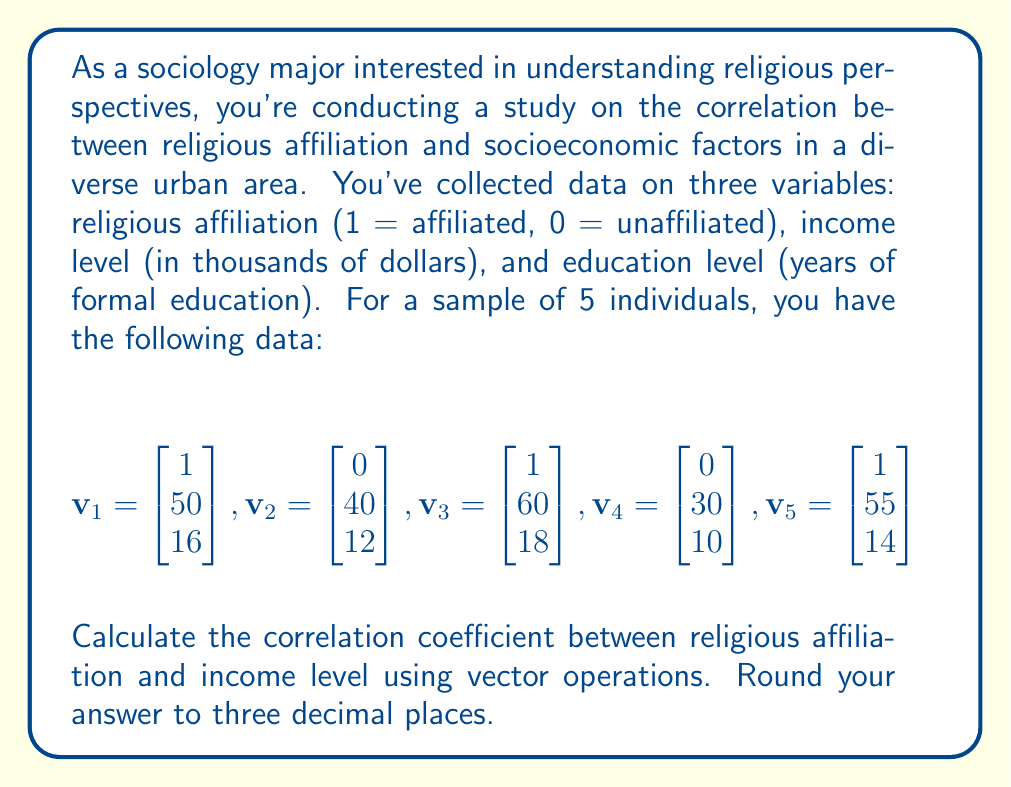Help me with this question. To calculate the correlation coefficient between religious affiliation and income level, we'll use the following steps:

1) First, we need to separate the religious affiliation data and income data into two vectors:

   $$\mathbf{x} = \begin{bmatrix} 1 \\ 0 \\ 1 \\ 0 \\ 1 \end{bmatrix}, \mathbf{y} = \begin{bmatrix} 50 \\ 40 \\ 60 \\ 30 \\ 55 \end{bmatrix}$$

2) Calculate the means of $\mathbf{x}$ and $\mathbf{y}$:
   
   $$\bar{x} = \frac{1}{5}(1+0+1+0+1) = 0.6$$
   $$\bar{y} = \frac{1}{5}(50+40+60+30+55) = 47$$

3) Calculate the centered vectors by subtracting the means:

   $$\mathbf{x}_c = \mathbf{x} - \bar{x} = \begin{bmatrix} 0.4 \\ -0.6 \\ 0.4 \\ -0.6 \\ 0.4 \end{bmatrix}$$
   $$\mathbf{y}_c = \mathbf{y} - \bar{y} = \begin{bmatrix} 3 \\ -7 \\ 13 \\ -17 \\ 8 \end{bmatrix}$$

4) The correlation coefficient is given by:

   $$r = \frac{\mathbf{x}_c \cdot \mathbf{y}_c}{\|\mathbf{x}_c\| \|\mathbf{y}_c\|}$$

   where $\cdot$ denotes the dot product and $\|\mathbf{v}\|$ is the Euclidean norm of vector $\mathbf{v}$.

5) Calculate the dot product $\mathbf{x}_c \cdot \mathbf{y}_c$:

   $$\mathbf{x}_c \cdot \mathbf{y}_c = 0.4(3) + (-0.6)(-7) + 0.4(13) + (-0.6)(-17) + 0.4(8) = 22.2$$

6) Calculate the norms:

   $$\|\mathbf{x}_c\| = \sqrt{0.4^2 + (-0.6)^2 + 0.4^2 + (-0.6)^2 + 0.4^2} = \sqrt{1.04} \approx 1.0198$$
   $$\|\mathbf{y}_c\| = \sqrt{3^2 + (-7)^2 + 13^2 + (-17)^2 + 8^2} = \sqrt{566} \approx 23.7907$$

7) Now, we can calculate the correlation coefficient:

   $$r = \frac{22.2}{1.0198 \times 23.7907} \approx 0.917$$
Answer: The correlation coefficient between religious affiliation and income level is approximately 0.917 (rounded to three decimal places). 